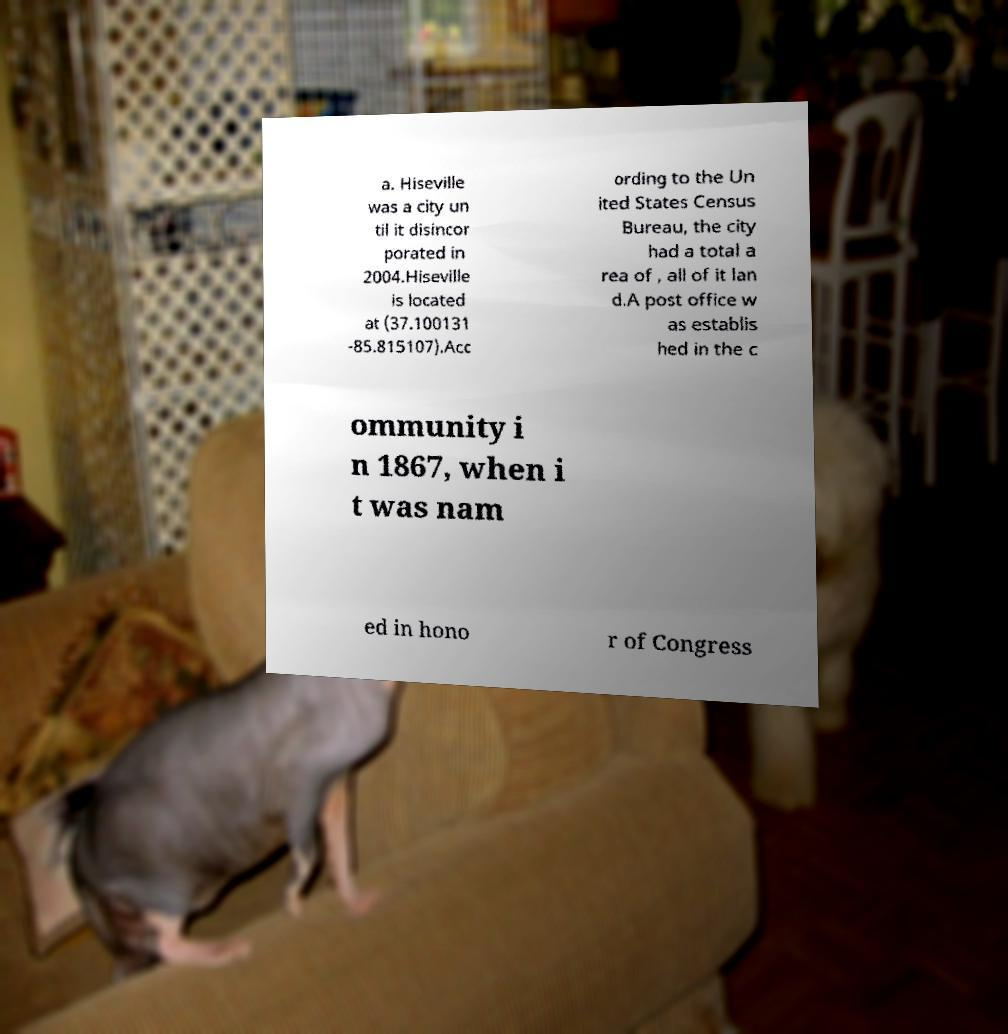I need the written content from this picture converted into text. Can you do that? a. Hiseville was a city un til it disincor porated in 2004.Hiseville is located at (37.100131 -85.815107).Acc ording to the Un ited States Census Bureau, the city had a total a rea of , all of it lan d.A post office w as establis hed in the c ommunity i n 1867, when i t was nam ed in hono r of Congress 